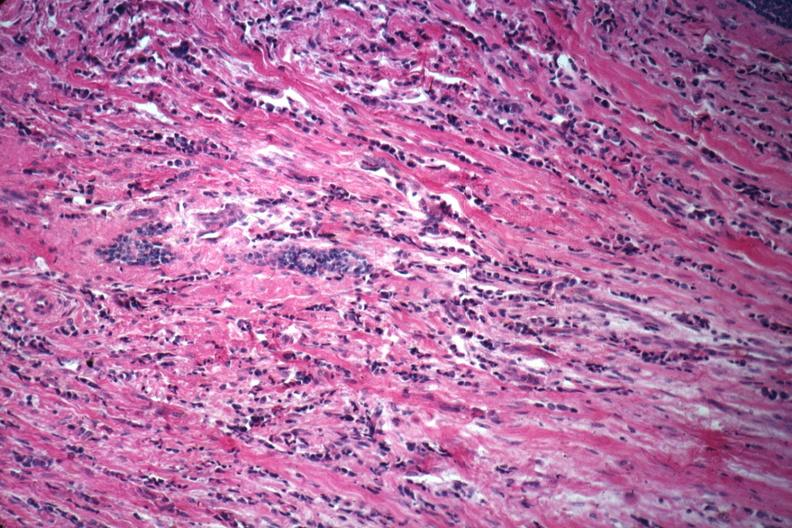what differentiated infiltrating ductal carcinoma?
Answer the question using a single word or phrase. Good example of poorly 